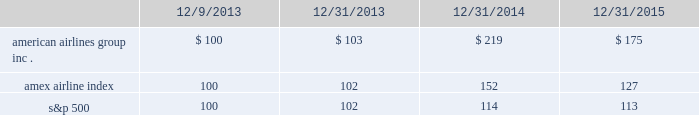Table of contents capital deployment program will be subject to market and economic conditions , applicable legal requirements and other relevant factors .
Our capital deployment program does not obligate us to continue a dividend for any fixed period , and payment of dividends may be suspended at any time at our discretion .
Stock performance graph the following stock performance graph and related information shall not be deemed 201csoliciting material 201d or 201cfiled 201d with the securities and exchange commission , nor shall such information be incorporated by reference into any future filings under the securities act of 1933 or the exchange act , each as amended , except to the extent that we specifically incorporate it by reference into such filing .
The following stock performance graph compares our cumulative total stockholder return on an annual basis on our common stock with the cumulative total return on the standard and poor 2019s 500 stock index and the amex airline index from december 9 , 2013 ( the first trading day of aag common stock ) through december 31 , 2015 .
The comparison assumes $ 100 was invested on december 9 , 2013 in aag common stock and in each of the foregoing indices and assumes reinvestment of dividends .
The stock performance shown on the graph below represents historical stock performance and is not necessarily indicative of future stock price performance. .
Purchases of equity securities by the issuer and affiliated purchasers since july 2014 , our board of directors has approved several share repurchase programs aggregating $ 7.0 billion of authority of which , as of december 31 , 2015 , $ 2.4 billion remained unused under repurchase programs .
What was the rate of growth or decrease from 2013 to 2014 on the amex airline index? 
Rationale: the growth rate is the difference between the most recent and prior amount divided by the prior amount
Computations: ((152 - 102) / 102)
Answer: 0.4902. 